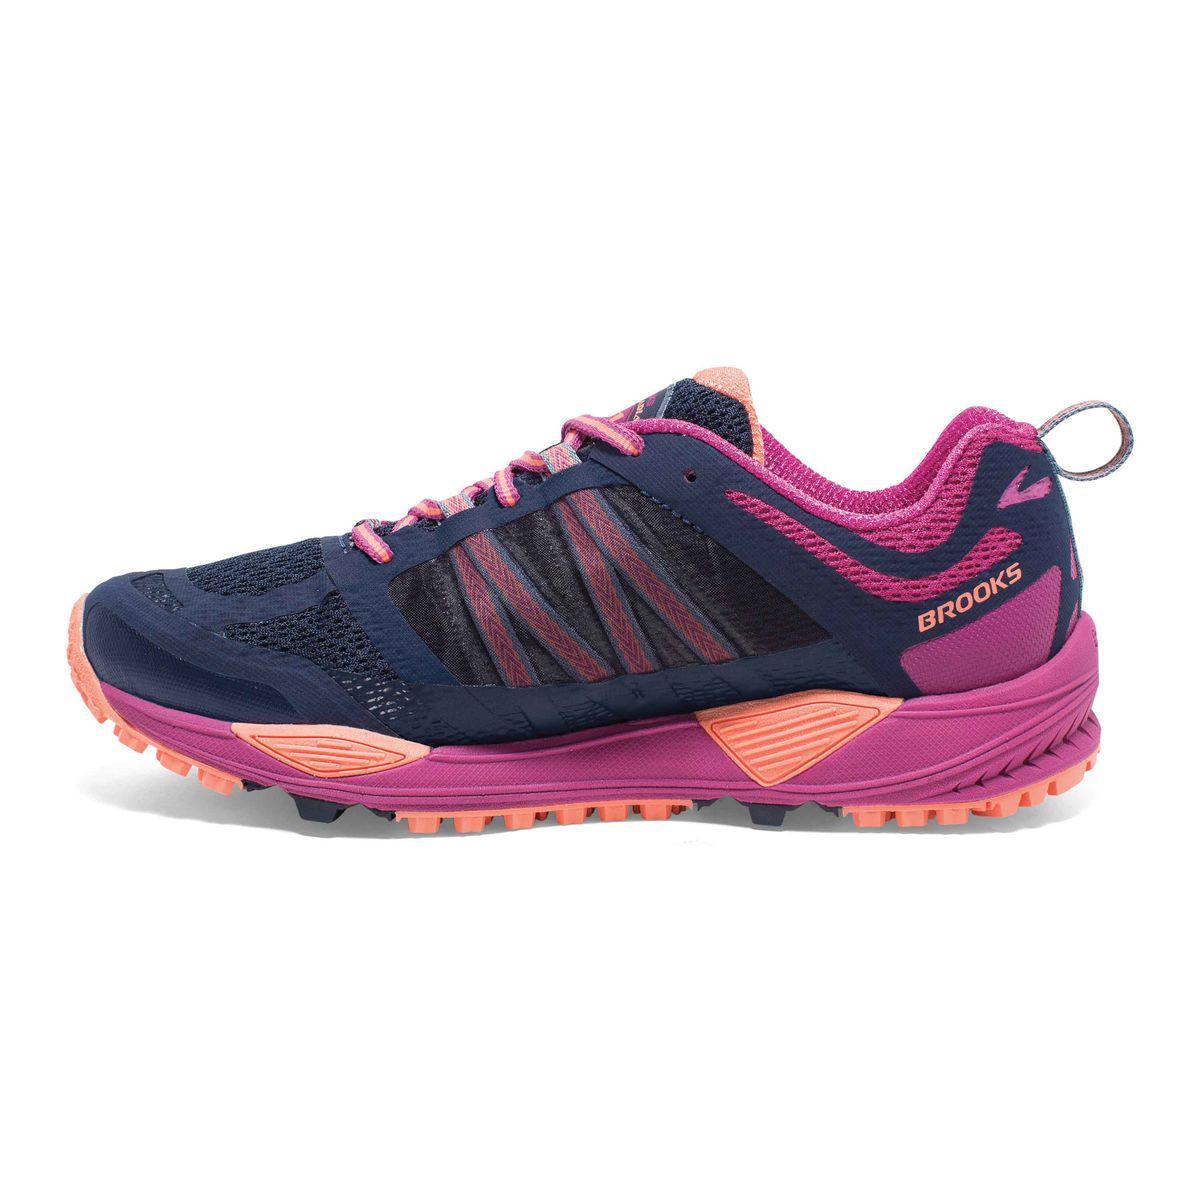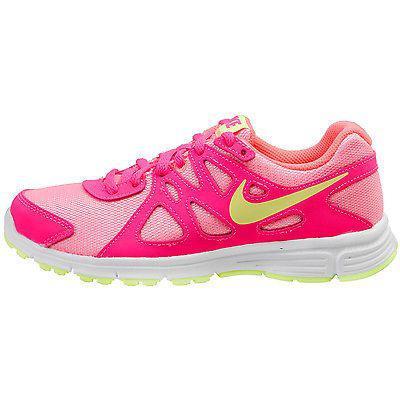The first image is the image on the left, the second image is the image on the right. Considering the images on both sides, is "The images show a total of two sneakers, both facing right." valid? Answer yes or no. No. 